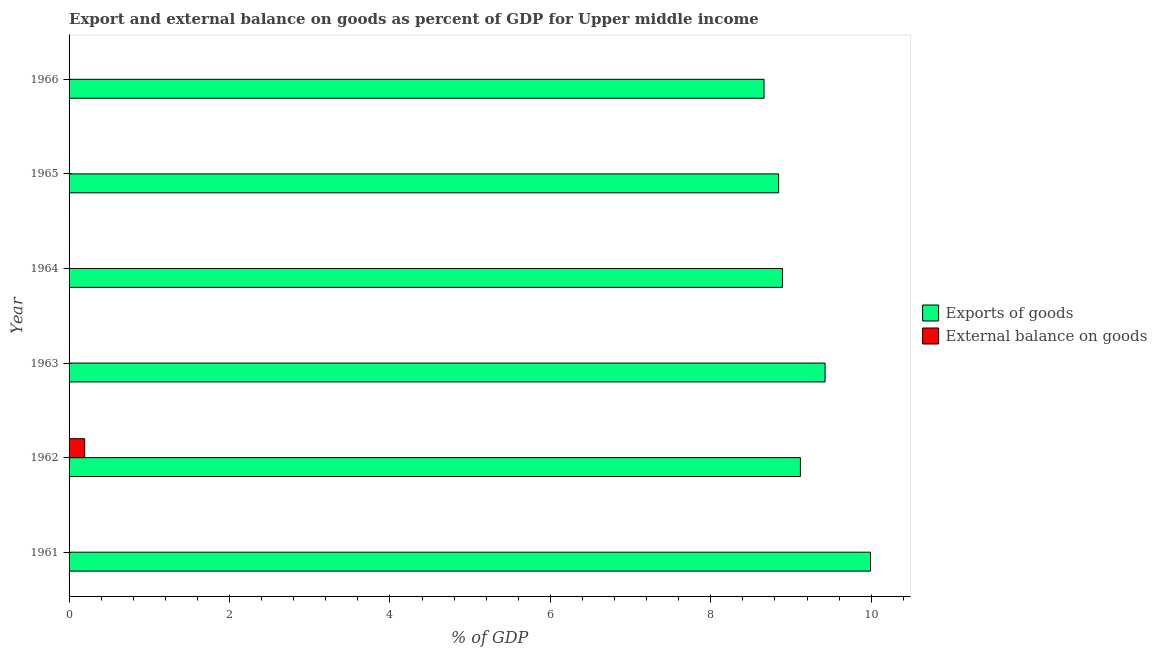How many bars are there on the 2nd tick from the top?
Your answer should be very brief. 1. How many bars are there on the 2nd tick from the bottom?
Offer a very short reply. 2. What is the label of the 1st group of bars from the top?
Offer a very short reply. 1966. In how many cases, is the number of bars for a given year not equal to the number of legend labels?
Your response must be concise. 5. What is the export of goods as percentage of gdp in 1961?
Ensure brevity in your answer.  9.99. Across all years, what is the maximum external balance on goods as percentage of gdp?
Make the answer very short. 0.19. Across all years, what is the minimum external balance on goods as percentage of gdp?
Keep it short and to the point. 0. In which year was the external balance on goods as percentage of gdp maximum?
Offer a very short reply. 1962. What is the total export of goods as percentage of gdp in the graph?
Your answer should be compact. 54.93. What is the difference between the export of goods as percentage of gdp in 1964 and that in 1966?
Ensure brevity in your answer.  0.23. What is the difference between the export of goods as percentage of gdp in 1965 and the external balance on goods as percentage of gdp in 1962?
Your answer should be very brief. 8.65. What is the average external balance on goods as percentage of gdp per year?
Keep it short and to the point. 0.03. In the year 1962, what is the difference between the export of goods as percentage of gdp and external balance on goods as percentage of gdp?
Offer a terse response. 8.92. What is the ratio of the export of goods as percentage of gdp in 1962 to that in 1965?
Give a very brief answer. 1.03. Is the export of goods as percentage of gdp in 1963 less than that in 1964?
Ensure brevity in your answer.  No. What is the difference between the highest and the second highest export of goods as percentage of gdp?
Provide a succinct answer. 0.57. What is the difference between the highest and the lowest export of goods as percentage of gdp?
Your answer should be very brief. 1.33. In how many years, is the export of goods as percentage of gdp greater than the average export of goods as percentage of gdp taken over all years?
Ensure brevity in your answer.  2. Are all the bars in the graph horizontal?
Keep it short and to the point. Yes. Are the values on the major ticks of X-axis written in scientific E-notation?
Provide a short and direct response. No. What is the title of the graph?
Give a very brief answer. Export and external balance on goods as percent of GDP for Upper middle income. What is the label or title of the X-axis?
Make the answer very short. % of GDP. What is the % of GDP of Exports of goods in 1961?
Your answer should be very brief. 9.99. What is the % of GDP of Exports of goods in 1962?
Your answer should be very brief. 9.12. What is the % of GDP in External balance on goods in 1962?
Offer a very short reply. 0.19. What is the % of GDP in Exports of goods in 1963?
Make the answer very short. 9.42. What is the % of GDP of Exports of goods in 1964?
Your answer should be very brief. 8.89. What is the % of GDP in External balance on goods in 1964?
Provide a short and direct response. 0. What is the % of GDP of Exports of goods in 1965?
Your answer should be compact. 8.85. What is the % of GDP of External balance on goods in 1965?
Your answer should be very brief. 0. What is the % of GDP in Exports of goods in 1966?
Offer a very short reply. 8.66. Across all years, what is the maximum % of GDP of Exports of goods?
Make the answer very short. 9.99. Across all years, what is the maximum % of GDP in External balance on goods?
Offer a very short reply. 0.19. Across all years, what is the minimum % of GDP in Exports of goods?
Offer a very short reply. 8.66. What is the total % of GDP in Exports of goods in the graph?
Offer a very short reply. 54.93. What is the total % of GDP of External balance on goods in the graph?
Your response must be concise. 0.19. What is the difference between the % of GDP of Exports of goods in 1961 and that in 1962?
Make the answer very short. 0.87. What is the difference between the % of GDP of Exports of goods in 1961 and that in 1963?
Your answer should be very brief. 0.57. What is the difference between the % of GDP of Exports of goods in 1961 and that in 1964?
Offer a terse response. 1.1. What is the difference between the % of GDP in Exports of goods in 1961 and that in 1965?
Provide a succinct answer. 1.15. What is the difference between the % of GDP in Exports of goods in 1961 and that in 1966?
Your answer should be very brief. 1.33. What is the difference between the % of GDP in Exports of goods in 1962 and that in 1963?
Provide a succinct answer. -0.31. What is the difference between the % of GDP of Exports of goods in 1962 and that in 1964?
Make the answer very short. 0.22. What is the difference between the % of GDP in Exports of goods in 1962 and that in 1965?
Offer a terse response. 0.27. What is the difference between the % of GDP of Exports of goods in 1962 and that in 1966?
Keep it short and to the point. 0.45. What is the difference between the % of GDP of Exports of goods in 1963 and that in 1964?
Make the answer very short. 0.53. What is the difference between the % of GDP in Exports of goods in 1963 and that in 1965?
Offer a very short reply. 0.58. What is the difference between the % of GDP in Exports of goods in 1963 and that in 1966?
Make the answer very short. 0.76. What is the difference between the % of GDP in Exports of goods in 1964 and that in 1965?
Offer a terse response. 0.05. What is the difference between the % of GDP of Exports of goods in 1964 and that in 1966?
Give a very brief answer. 0.23. What is the difference between the % of GDP in Exports of goods in 1965 and that in 1966?
Your answer should be very brief. 0.18. What is the difference between the % of GDP in Exports of goods in 1961 and the % of GDP in External balance on goods in 1962?
Offer a terse response. 9.8. What is the average % of GDP of Exports of goods per year?
Offer a very short reply. 9.16. What is the average % of GDP of External balance on goods per year?
Keep it short and to the point. 0.03. In the year 1962, what is the difference between the % of GDP of Exports of goods and % of GDP of External balance on goods?
Your answer should be compact. 8.92. What is the ratio of the % of GDP in Exports of goods in 1961 to that in 1962?
Keep it short and to the point. 1.1. What is the ratio of the % of GDP of Exports of goods in 1961 to that in 1963?
Provide a succinct answer. 1.06. What is the ratio of the % of GDP in Exports of goods in 1961 to that in 1964?
Your answer should be very brief. 1.12. What is the ratio of the % of GDP in Exports of goods in 1961 to that in 1965?
Offer a very short reply. 1.13. What is the ratio of the % of GDP of Exports of goods in 1961 to that in 1966?
Your response must be concise. 1.15. What is the ratio of the % of GDP of Exports of goods in 1962 to that in 1963?
Your answer should be compact. 0.97. What is the ratio of the % of GDP in Exports of goods in 1962 to that in 1964?
Make the answer very short. 1.03. What is the ratio of the % of GDP of Exports of goods in 1962 to that in 1965?
Ensure brevity in your answer.  1.03. What is the ratio of the % of GDP in Exports of goods in 1962 to that in 1966?
Your answer should be very brief. 1.05. What is the ratio of the % of GDP of Exports of goods in 1963 to that in 1964?
Make the answer very short. 1.06. What is the ratio of the % of GDP of Exports of goods in 1963 to that in 1965?
Offer a terse response. 1.07. What is the ratio of the % of GDP of Exports of goods in 1963 to that in 1966?
Keep it short and to the point. 1.09. What is the ratio of the % of GDP of Exports of goods in 1964 to that in 1966?
Provide a succinct answer. 1.03. What is the difference between the highest and the second highest % of GDP in Exports of goods?
Give a very brief answer. 0.57. What is the difference between the highest and the lowest % of GDP in Exports of goods?
Your answer should be very brief. 1.33. What is the difference between the highest and the lowest % of GDP of External balance on goods?
Provide a succinct answer. 0.19. 